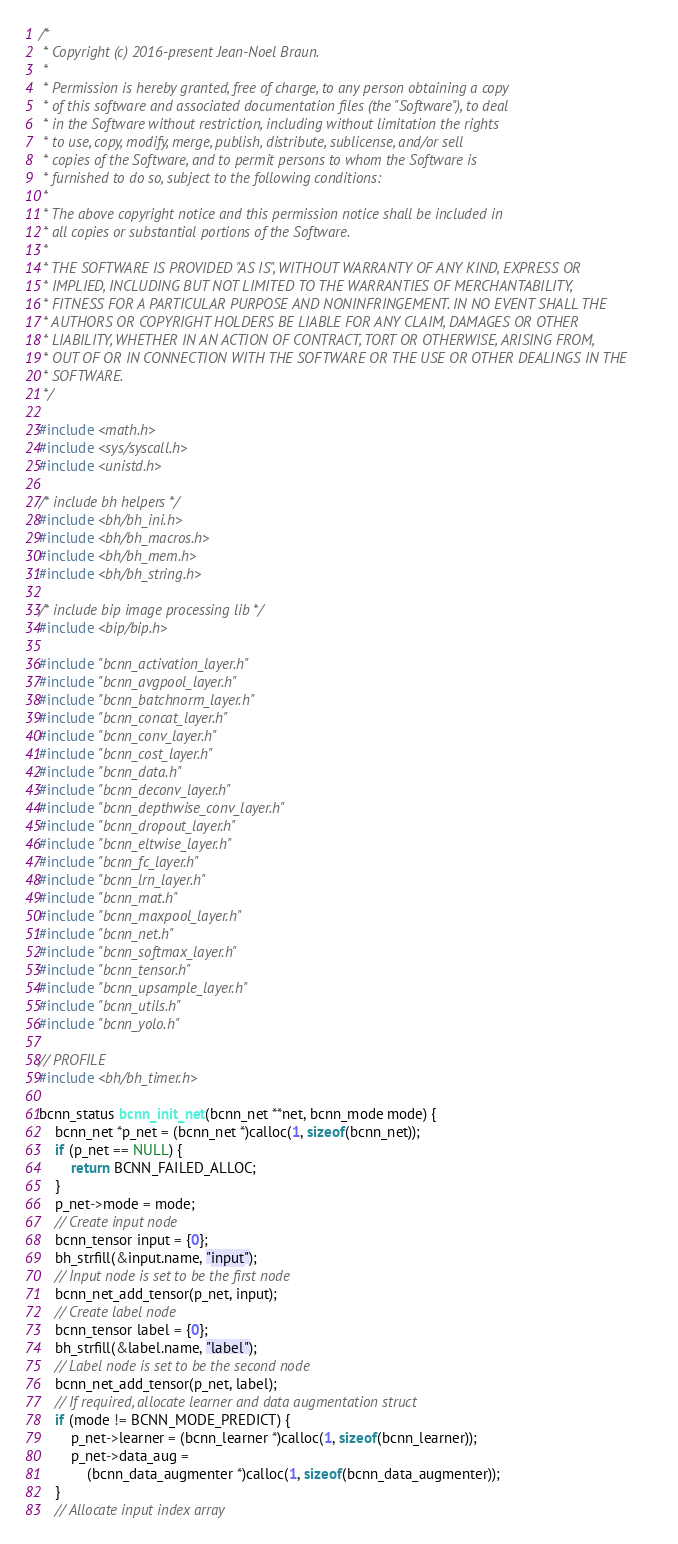Convert code to text. <code><loc_0><loc_0><loc_500><loc_500><_C_>/*
 * Copyright (c) 2016-present Jean-Noel Braun.
 *
 * Permission is hereby granted, free of charge, to any person obtaining a copy
 * of this software and associated documentation files (the "Software"), to deal
 * in the Software without restriction, including without limitation the rights
 * to use, copy, modify, merge, publish, distribute, sublicense, and/or sell
 * copies of the Software, and to permit persons to whom the Software is
 * furnished to do so, subject to the following conditions:
 *
 * The above copyright notice and this permission notice shall be included in
 * all copies or substantial portions of the Software.
 *
 * THE SOFTWARE IS PROVIDED "AS IS", WITHOUT WARRANTY OF ANY KIND, EXPRESS OR
 * IMPLIED, INCLUDING BUT NOT LIMITED TO THE WARRANTIES OF MERCHANTABILITY,
 * FITNESS FOR A PARTICULAR PURPOSE AND NONINFRINGEMENT. IN NO EVENT SHALL THE
 * AUTHORS OR COPYRIGHT HOLDERS BE LIABLE FOR ANY CLAIM, DAMAGES OR OTHER
 * LIABILITY, WHETHER IN AN ACTION OF CONTRACT, TORT OR OTHERWISE, ARISING FROM,
 * OUT OF OR IN CONNECTION WITH THE SOFTWARE OR THE USE OR OTHER DEALINGS IN THE
 * SOFTWARE.
 */

#include <math.h>
#include <sys/syscall.h>
#include <unistd.h>

/* include bh helpers */
#include <bh/bh_ini.h>
#include <bh/bh_macros.h>
#include <bh/bh_mem.h>
#include <bh/bh_string.h>

/* include bip image processing lib */
#include <bip/bip.h>

#include "bcnn_activation_layer.h"
#include "bcnn_avgpool_layer.h"
#include "bcnn_batchnorm_layer.h"
#include "bcnn_concat_layer.h"
#include "bcnn_conv_layer.h"
#include "bcnn_cost_layer.h"
#include "bcnn_data.h"
#include "bcnn_deconv_layer.h"
#include "bcnn_depthwise_conv_layer.h"
#include "bcnn_dropout_layer.h"
#include "bcnn_eltwise_layer.h"
#include "bcnn_fc_layer.h"
#include "bcnn_lrn_layer.h"
#include "bcnn_mat.h"
#include "bcnn_maxpool_layer.h"
#include "bcnn_net.h"
#include "bcnn_softmax_layer.h"
#include "bcnn_tensor.h"
#include "bcnn_upsample_layer.h"
#include "bcnn_utils.h"
#include "bcnn_yolo.h"

// PROFILE
#include <bh/bh_timer.h>

bcnn_status bcnn_init_net(bcnn_net **net, bcnn_mode mode) {
    bcnn_net *p_net = (bcnn_net *)calloc(1, sizeof(bcnn_net));
    if (p_net == NULL) {
        return BCNN_FAILED_ALLOC;
    }
    p_net->mode = mode;
    // Create input node
    bcnn_tensor input = {0};
    bh_strfill(&input.name, "input");
    // Input node is set to be the first node
    bcnn_net_add_tensor(p_net, input);
    // Create label node
    bcnn_tensor label = {0};
    bh_strfill(&label.name, "label");
    // Label node is set to be the second node
    bcnn_net_add_tensor(p_net, label);
    // If required, allocate learner and data augmentation struct
    if (mode != BCNN_MODE_PREDICT) {
        p_net->learner = (bcnn_learner *)calloc(1, sizeof(bcnn_learner));
        p_net->data_aug =
            (bcnn_data_augmenter *)calloc(1, sizeof(bcnn_data_augmenter));
    }
    // Allocate input index array</code> 